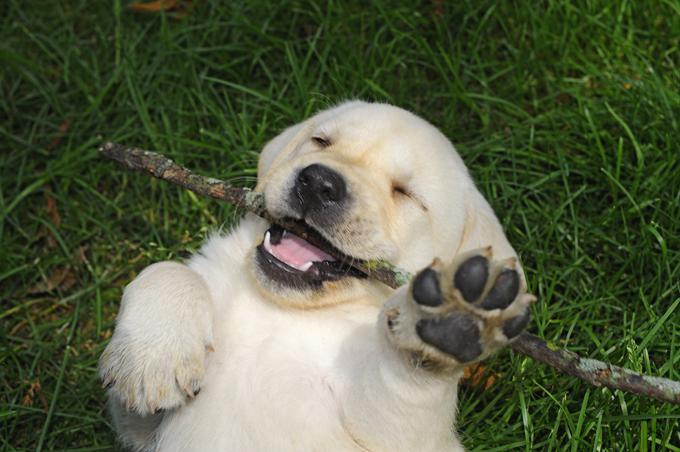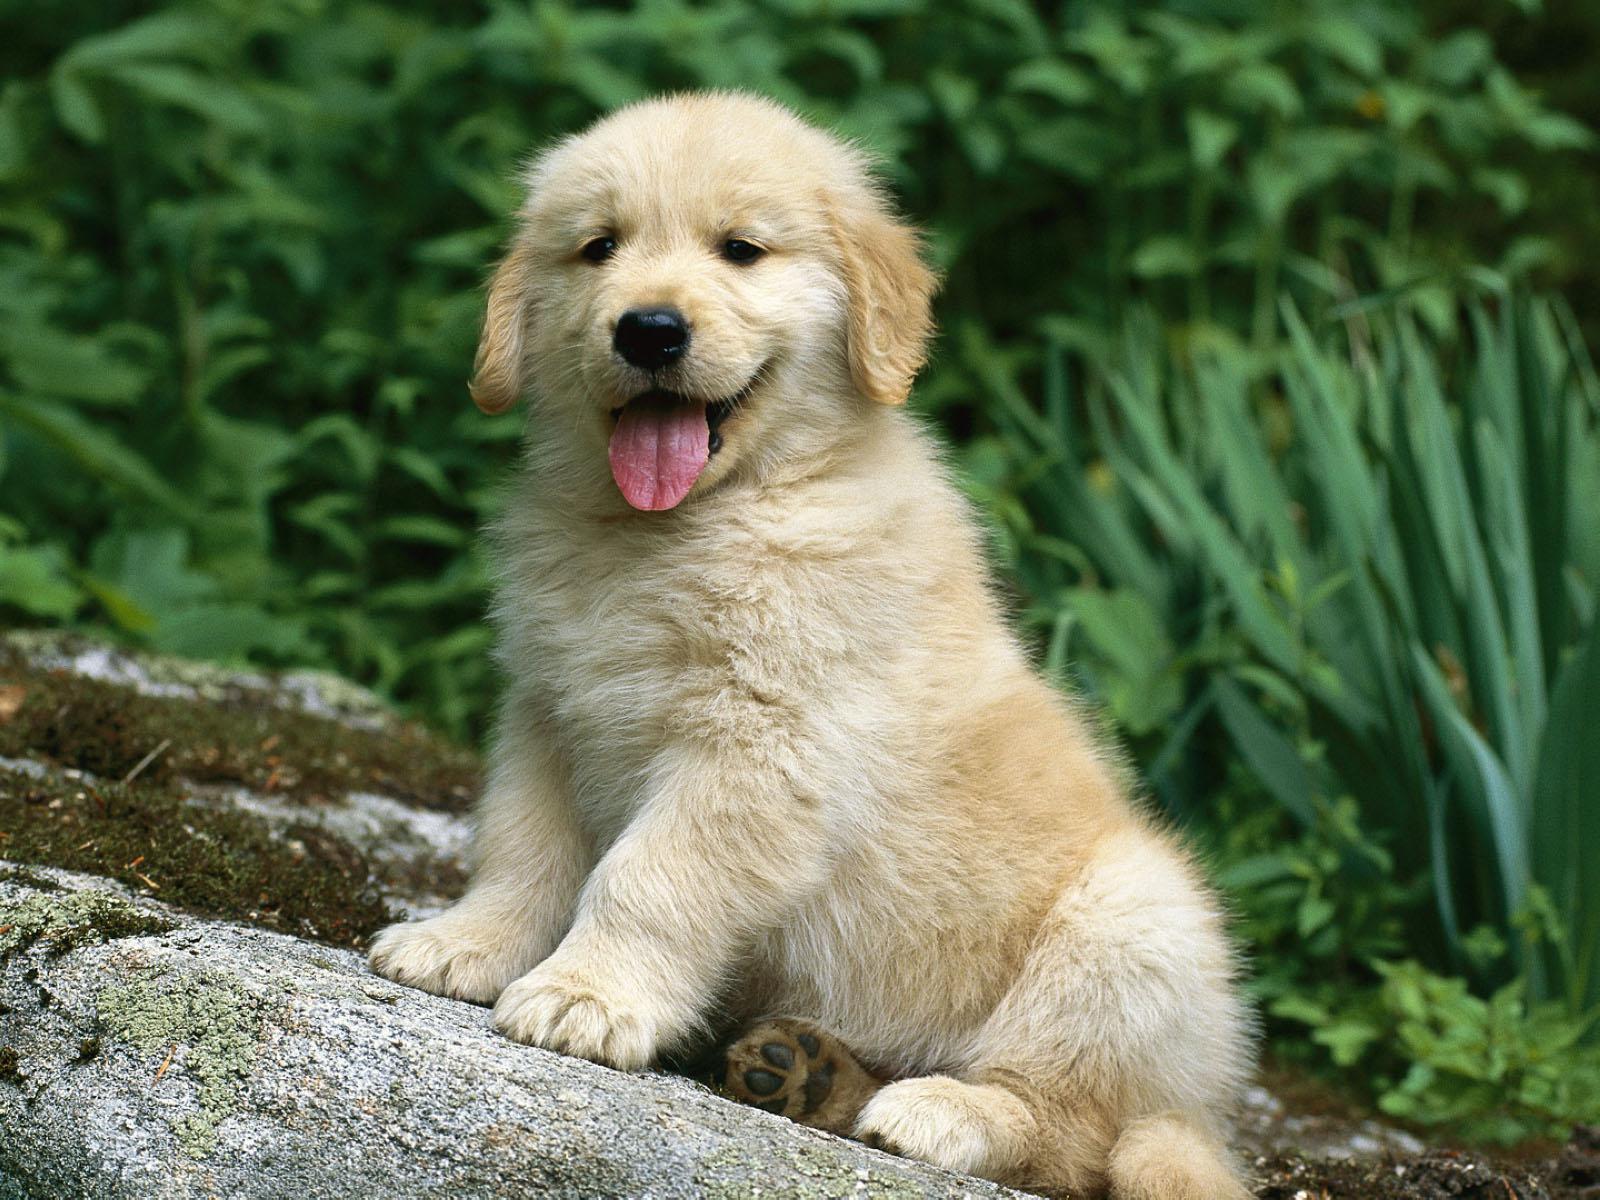The first image is the image on the left, the second image is the image on the right. Considering the images on both sides, is "one of the dogs is showing its teeth" valid? Answer yes or no. Yes. The first image is the image on the left, the second image is the image on the right. Considering the images on both sides, is "There are exactly two young puppies in each set of images." valid? Answer yes or no. Yes. The first image is the image on the left, the second image is the image on the right. For the images displayed, is the sentence "One of the images shows a dog with a dog toy in their possession." factually correct? Answer yes or no. No. 